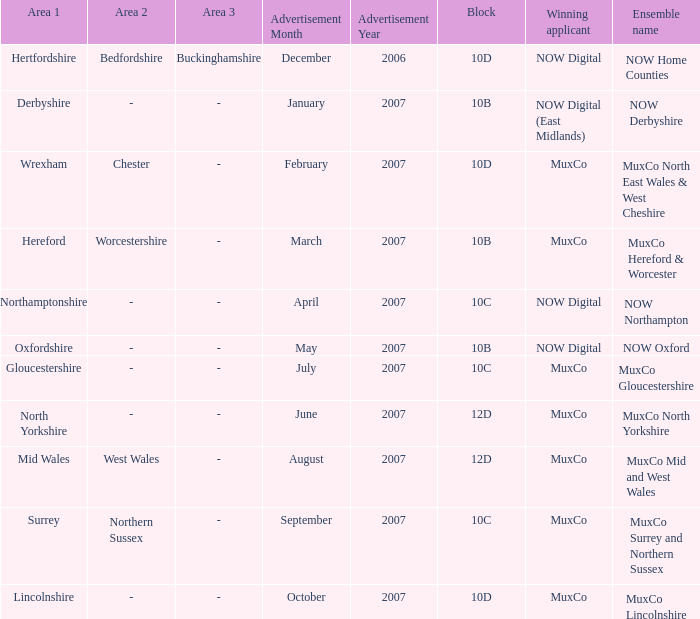Which Ensemble Name has the Advertisement date October 2007? MuxCo Lincolnshire. 